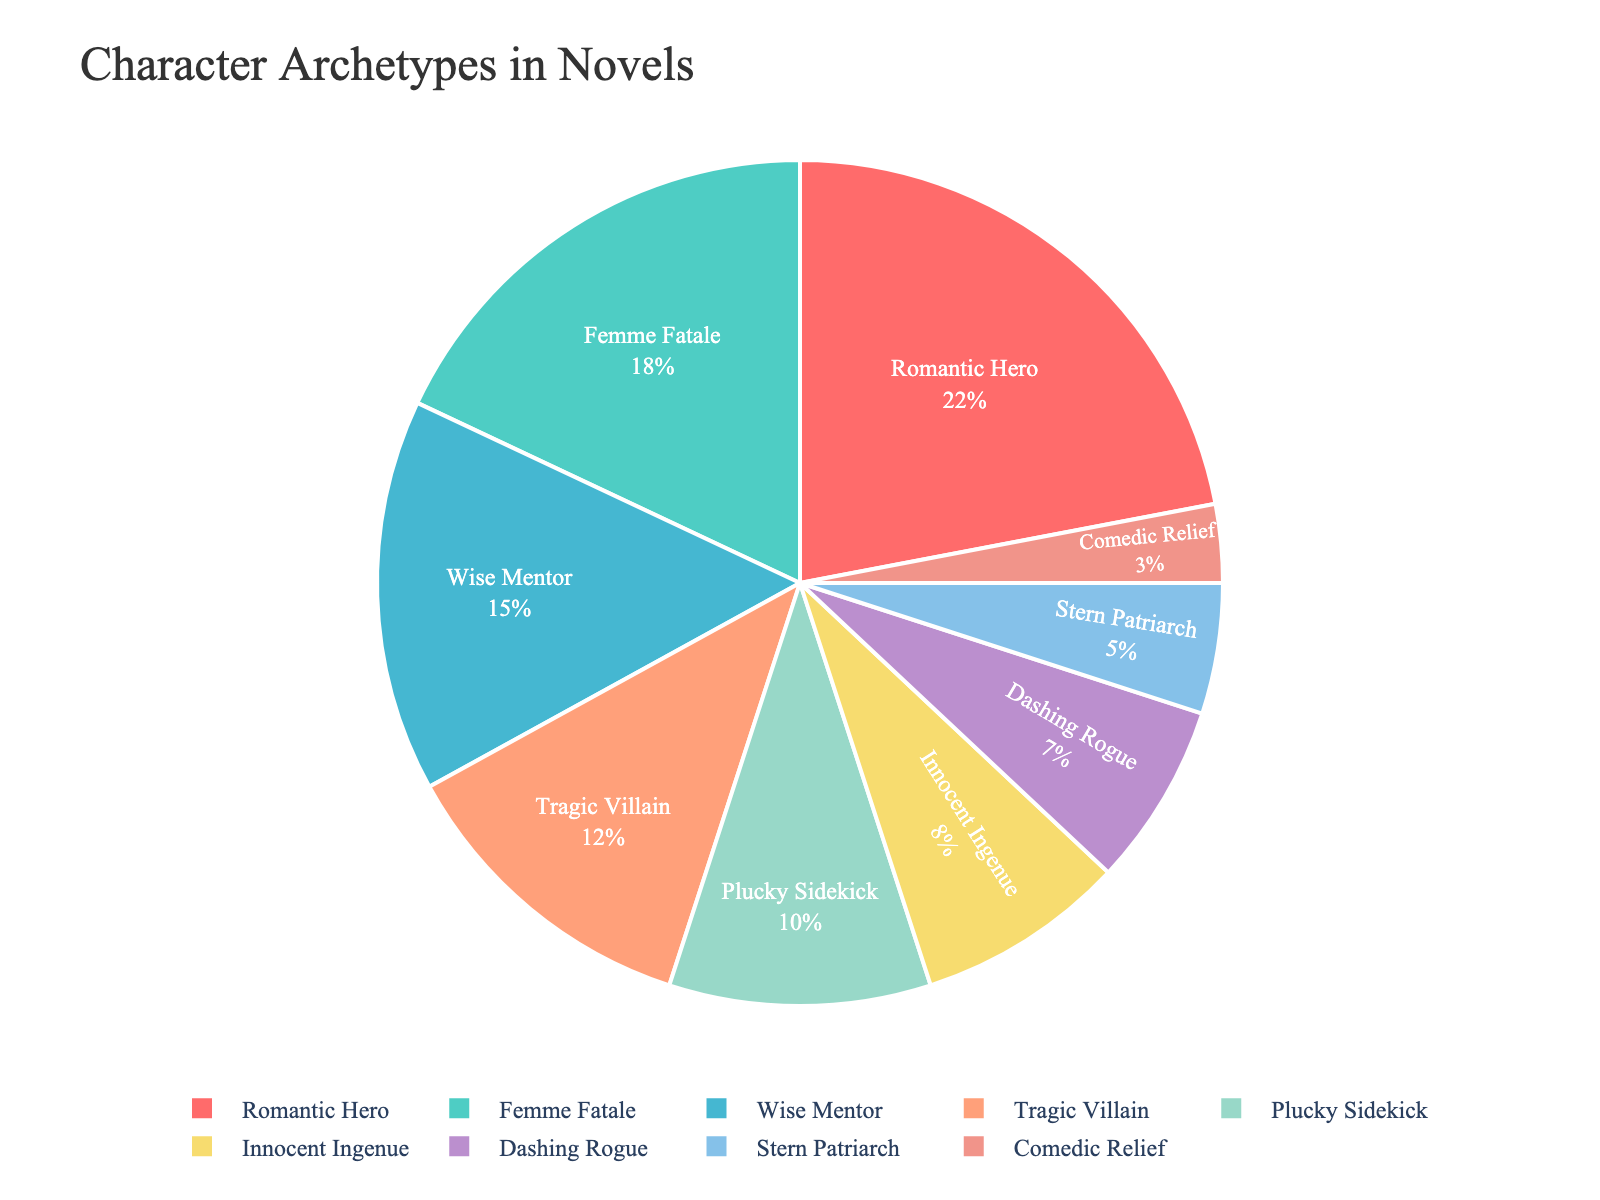Which character archetype has the largest proportion? The pie chart shows that the "Romantic Hero" segment is the largest by proportion, which can be visually confirmed by noting it's the most substantial slice of the pie.
Answer: Romantic Hero How much larger is the proportion of the Romantic Hero compared to the Comedic Relief? The pie chart shows that the Romantic Hero is 22% and Comedic Relief is 3%. The difference in proportion is 22% - 3% = 19%.
Answer: 19% What is the combined proportion of the Femme Fatale and Wise Mentor archetypes? From the pie chart, the Femme Fatale is 18% and the Wise Mentor is 15%. Summing these proportions gives 18% + 15% = 33%.
Answer: 33% Which character archetype has the smallest proportion? The pie chart shows that the "Comedic Relief" segment is the smallest by proportion. This can be confirmed by locating the smallest slice of the pie.
Answer: Comedic Relief Does the proportion of the Tragic Villain exceed that of the Plucky Sidekick? The pie chart indicates that the Tragic Villain has a proportion of 12% while the Plucky Sidekick has 10%. Therefore, the Tragic Villain's proportion does exceed that of the Plucky Sidekick.
Answer: Yes What is the total proportion of character archetypes that have a proportion less than 10%? According to the pie chart, the archetypes with less than 10% are Innocent Ingenue (8%), Dashing Rogue (7%), Stern Patriarch (5%), and Comedic Relief (3%). Summing these proportions gives 8% + 7% + 5% + 3% = 23%.
Answer: 23% What proportion of the plot is taken up by the three most frequent character archetypes? The three most frequent archetypes (as shown in the pie chart) are Romantic Hero (22%), Femme Fatale (18%), and Wise Mentor (15%). Summing these proportions gives 22% + 18% + 15% = 55%.
Answer: 55% Which character archetype is represented by a light purple color on the plot? By visually inspecting the pie chart, it is clear that the "BB8FCE" color corresponds to the Dashing Rogue archetype.
Answer: Dashing Rogue How does the proportion of the Stern Patriarch compare to the Innocent Ingenue? The pie chart shows that the Stern Patriarch's proportion (5%) is smaller than the Innocent Ingenue's proportion (8%).
Answer: Smaller 